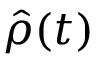<formula> <loc_0><loc_0><loc_500><loc_500>{ \hat { \rho } } ( t )</formula> 